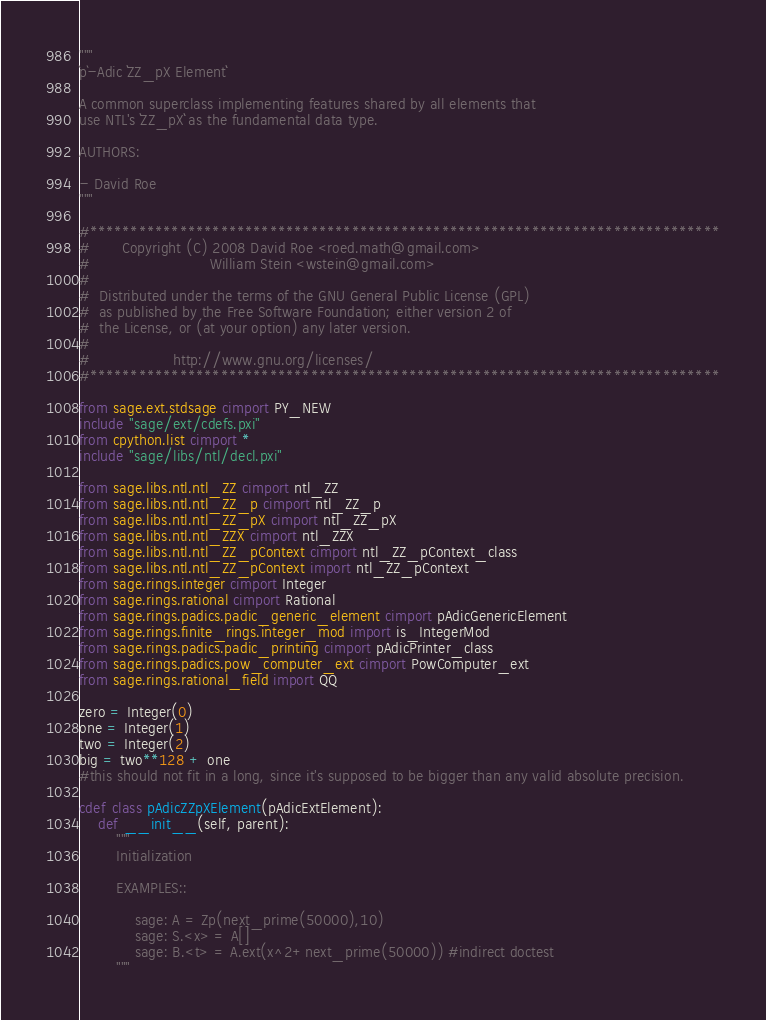<code> <loc_0><loc_0><loc_500><loc_500><_Cython_>"""
`p`-Adic ``ZZ_pX Element``

A common superclass implementing features shared by all elements that
use NTL's ``ZZ_pX`` as the fundamental data type.

AUTHORS:

- David Roe
"""

#*****************************************************************************
#       Copyright (C) 2008 David Roe <roed.math@gmail.com>
#                          William Stein <wstein@gmail.com>
#
#  Distributed under the terms of the GNU General Public License (GPL)
#  as published by the Free Software Foundation; either version 2 of
#  the License, or (at your option) any later version.
#
#                  http://www.gnu.org/licenses/
#*****************************************************************************

from sage.ext.stdsage cimport PY_NEW
include "sage/ext/cdefs.pxi"
from cpython.list cimport *
include "sage/libs/ntl/decl.pxi"

from sage.libs.ntl.ntl_ZZ cimport ntl_ZZ
from sage.libs.ntl.ntl_ZZ_p cimport ntl_ZZ_p
from sage.libs.ntl.ntl_ZZ_pX cimport ntl_ZZ_pX
from sage.libs.ntl.ntl_ZZX cimport ntl_ZZX
from sage.libs.ntl.ntl_ZZ_pContext cimport ntl_ZZ_pContext_class
from sage.libs.ntl.ntl_ZZ_pContext import ntl_ZZ_pContext
from sage.rings.integer cimport Integer
from sage.rings.rational cimport Rational
from sage.rings.padics.padic_generic_element cimport pAdicGenericElement
from sage.rings.finite_rings.integer_mod import is_IntegerMod
from sage.rings.padics.padic_printing cimport pAdicPrinter_class
from sage.rings.padics.pow_computer_ext cimport PowComputer_ext
from sage.rings.rational_field import QQ

zero = Integer(0)
one = Integer(1)
two = Integer(2)
big = two**128 + one
#this should not fit in a long, since it's supposed to be bigger than any valid absolute precision.

cdef class pAdicZZpXElement(pAdicExtElement):
    def __init__(self, parent):
        """
        Initialization

        EXAMPLES::

            sage: A = Zp(next_prime(50000),10)
            sage: S.<x> = A[]
            sage: B.<t> = A.ext(x^2+next_prime(50000)) #indirect doctest
        """</code> 